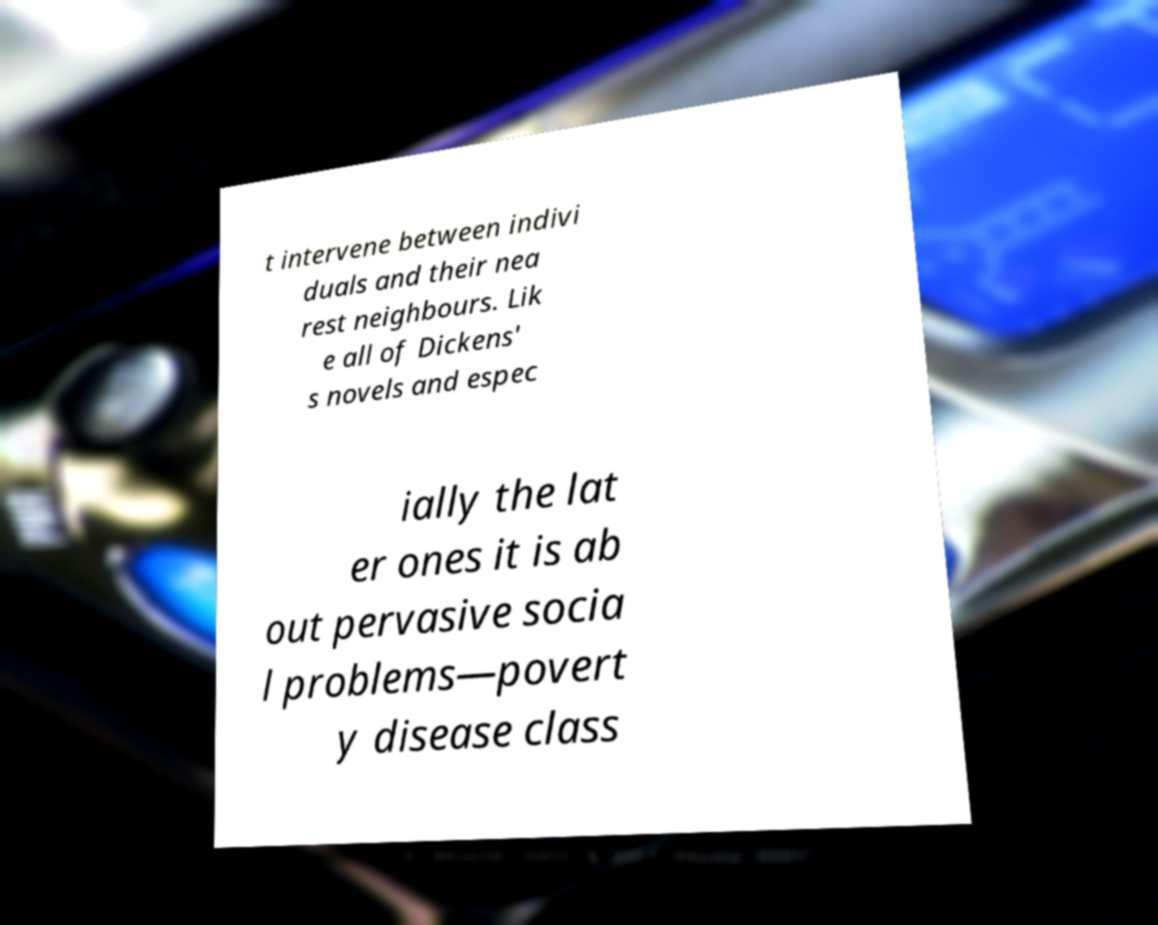Can you accurately transcribe the text from the provided image for me? t intervene between indivi duals and their nea rest neighbours. Lik e all of Dickens' s novels and espec ially the lat er ones it is ab out pervasive socia l problems—povert y disease class 